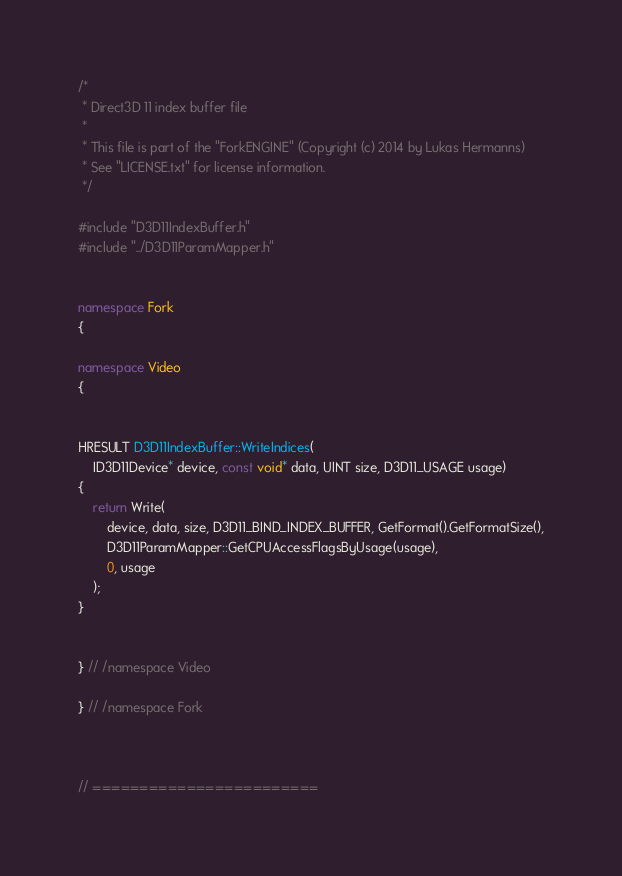Convert code to text. <code><loc_0><loc_0><loc_500><loc_500><_C++_>/*
 * Direct3D 11 index buffer file
 * 
 * This file is part of the "ForkENGINE" (Copyright (c) 2014 by Lukas Hermanns)
 * See "LICENSE.txt" for license information.
 */

#include "D3D11IndexBuffer.h"
#include "../D3D11ParamMapper.h"


namespace Fork
{

namespace Video
{


HRESULT D3D11IndexBuffer::WriteIndices(
    ID3D11Device* device, const void* data, UINT size, D3D11_USAGE usage)
{
    return Write(
        device, data, size, D3D11_BIND_INDEX_BUFFER, GetFormat().GetFormatSize(),
        D3D11ParamMapper::GetCPUAccessFlagsByUsage(usage),
        0, usage
    );
}


} // /namespace Video

} // /namespace Fork



// ========================</code> 